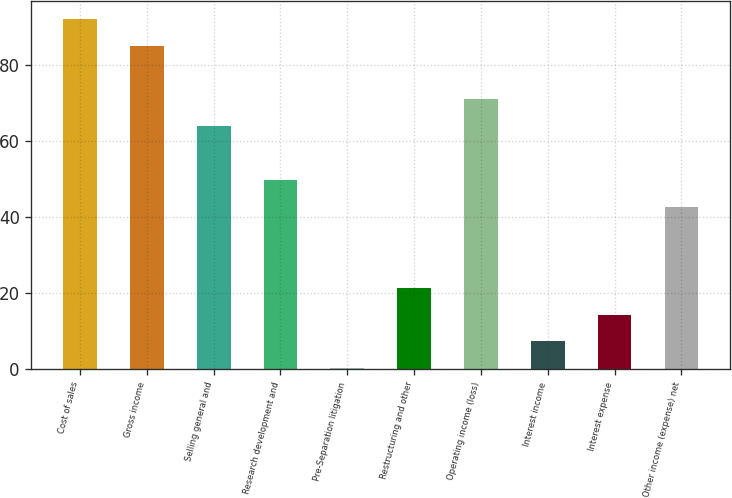Convert chart. <chart><loc_0><loc_0><loc_500><loc_500><bar_chart><fcel>Cost of sales<fcel>Gross income<fcel>Selling general and<fcel>Research development and<fcel>Pre-Separation litigation<fcel>Restructuring and other<fcel>Operating income (loss)<fcel>Interest income<fcel>Interest expense<fcel>Other income (expense) net<nl><fcel>92.24<fcel>85.16<fcel>63.92<fcel>49.76<fcel>0.2<fcel>21.44<fcel>71<fcel>7.28<fcel>14.36<fcel>42.68<nl></chart> 